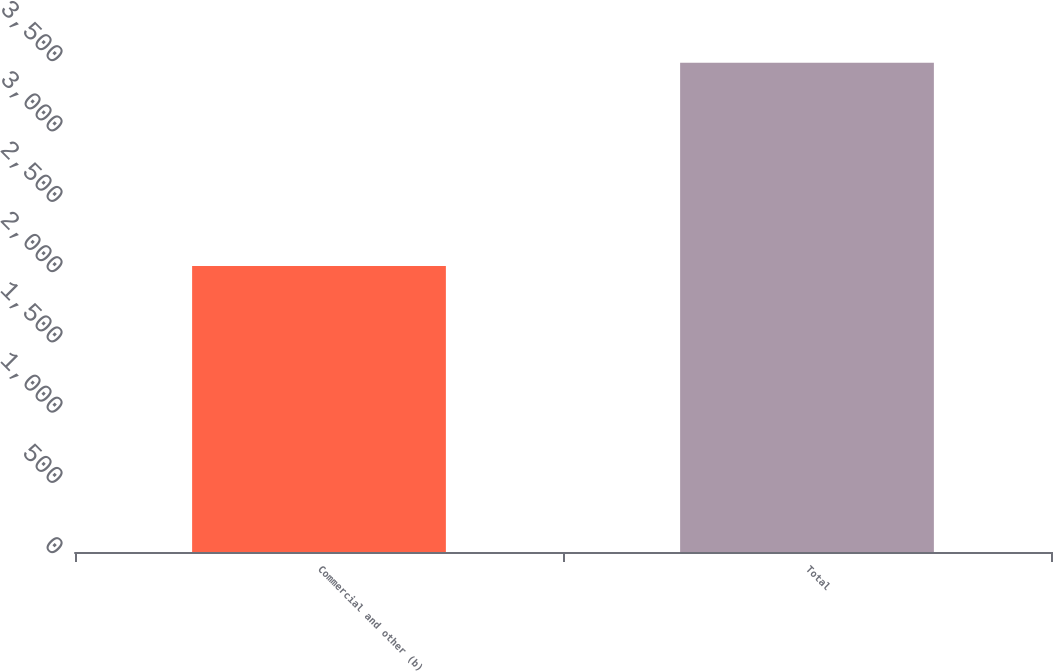Convert chart to OTSL. <chart><loc_0><loc_0><loc_500><loc_500><bar_chart><fcel>Commercial and other (b)<fcel>Total<nl><fcel>2035<fcel>3481<nl></chart> 